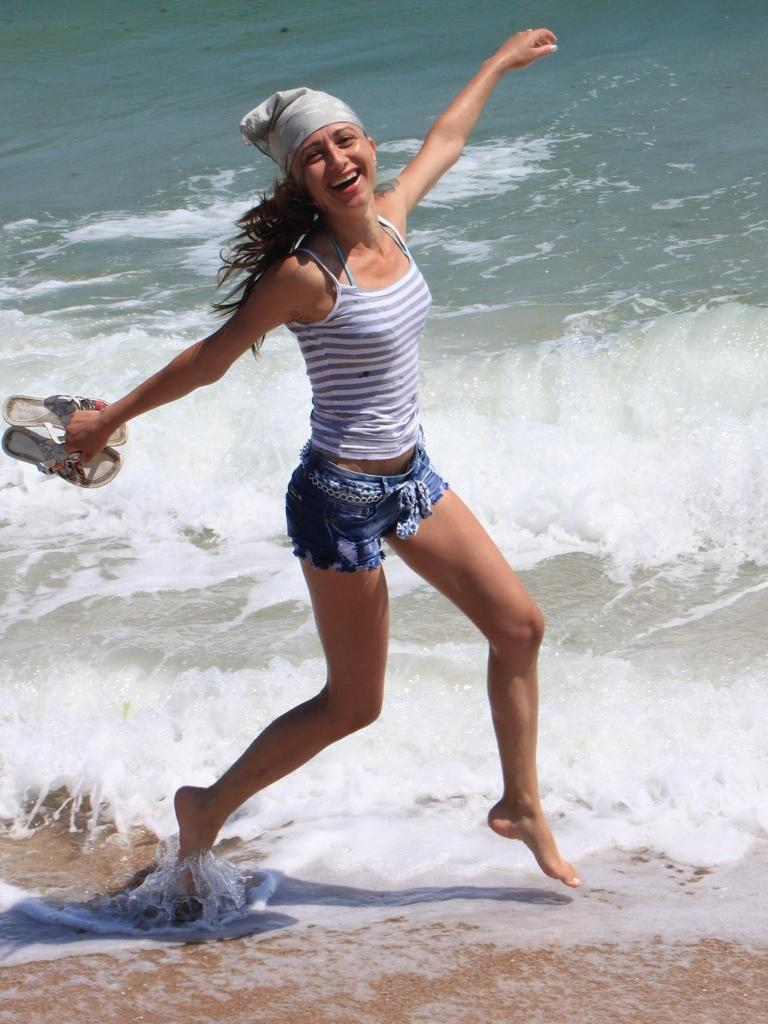Who is present in the image? There is a woman in the image. What is the woman holding in the image? The woman is holding slippers. What is the woman's facial expression in the image? The woman is smiling. What can be seen in the background of the image? There is water visible in the background of the image. What type of whip can be seen in the woman's hand in the image? There is no whip present in the woman's hand or in the image. 